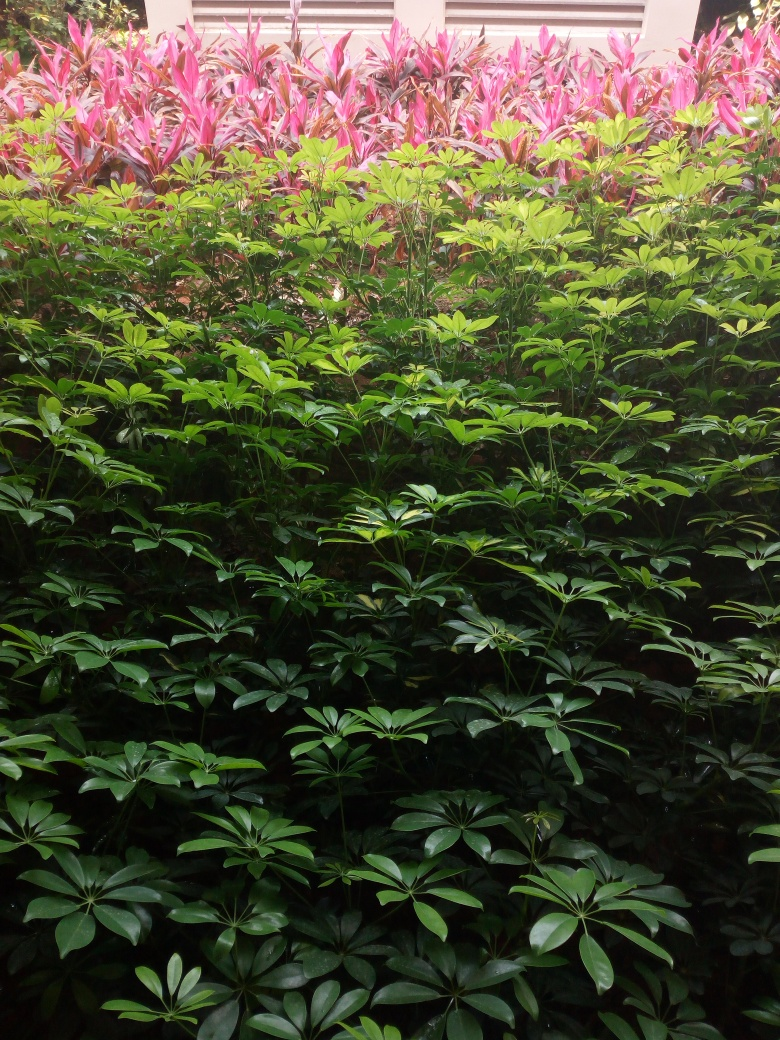Are the texture details unclear?
A. Yes
B. No
Answer with the option's letter from the given choices directly.
 B. 